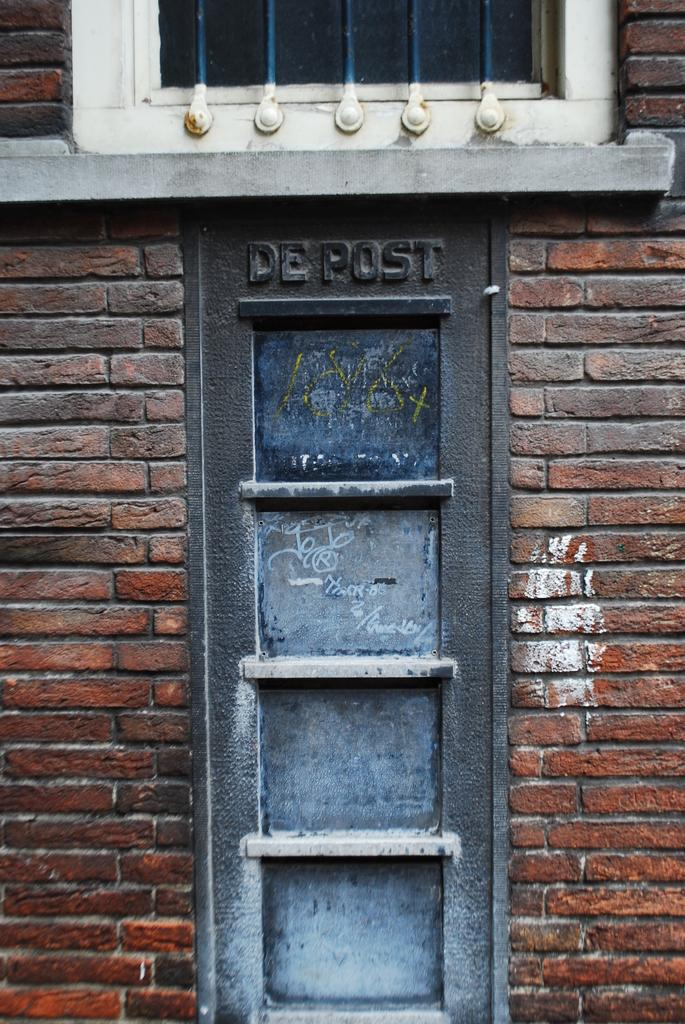What type of structure can be seen in the image? There is a wall in the image. Is there any opening in the wall? Yes, there is a window at the top of the wall. What else can be seen on the wall? There is text visible on the wall. What type of mass is being conducted in the image? There is no mass or religious ceremony visible in the image; it only features a wall with a window and text. 